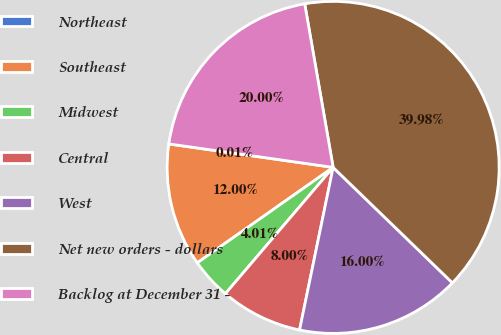Convert chart. <chart><loc_0><loc_0><loc_500><loc_500><pie_chart><fcel>Northeast<fcel>Southeast<fcel>Midwest<fcel>Central<fcel>West<fcel>Net new orders - dollars<fcel>Backlog at December 31 -<nl><fcel>0.01%<fcel>12.0%<fcel>4.01%<fcel>8.0%<fcel>16.0%<fcel>39.98%<fcel>20.0%<nl></chart> 